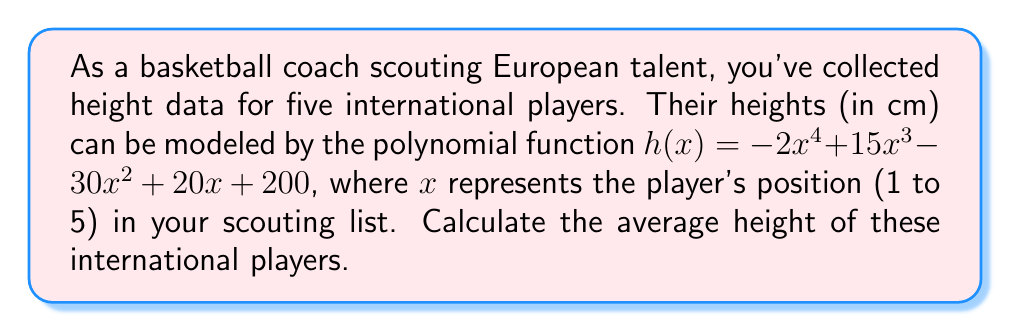Can you solve this math problem? To solve this problem, we need to follow these steps:

1) First, we need to calculate the height of each player by evaluating the function $h(x)$ for $x = 1, 2, 3, 4,$ and $5$.

2) For $x = 1$:
   $h(1) = -2(1)^4 + 15(1)^3 - 30(1)^2 + 20(1) + 200 = -2 + 15 - 30 + 20 + 200 = 203$ cm

3) For $x = 2$:
   $h(2) = -2(2)^4 + 15(2)^3 - 30(2)^2 + 20(2) + 200 = -32 + 120 - 120 + 40 + 200 = 208$ cm

4) For $x = 3$:
   $h(3) = -2(3)^4 + 15(3)^3 - 30(3)^2 + 20(3) + 200 = -162 + 405 - 270 + 60 + 200 = 233$ cm

5) For $x = 4$:
   $h(4) = -2(4)^4 + 15(4)^3 - 30(4)^2 + 20(4) + 200 = -512 + 960 - 480 + 80 + 200 = 248$ cm

6) For $x = 5$:
   $h(5) = -2(5)^4 + 15(5)^3 - 30(5)^2 + 20(5) + 200 = -1250 + 1875 - 750 + 100 + 200 = 175$ cm

7) Now that we have the heights of all five players, we can calculate the average:

   Average Height = $\frac{203 + 208 + 233 + 248 + 175}{5} = \frac{1067}{5} = 213.4$ cm
Answer: The average height of the five international players is 213.4 cm. 